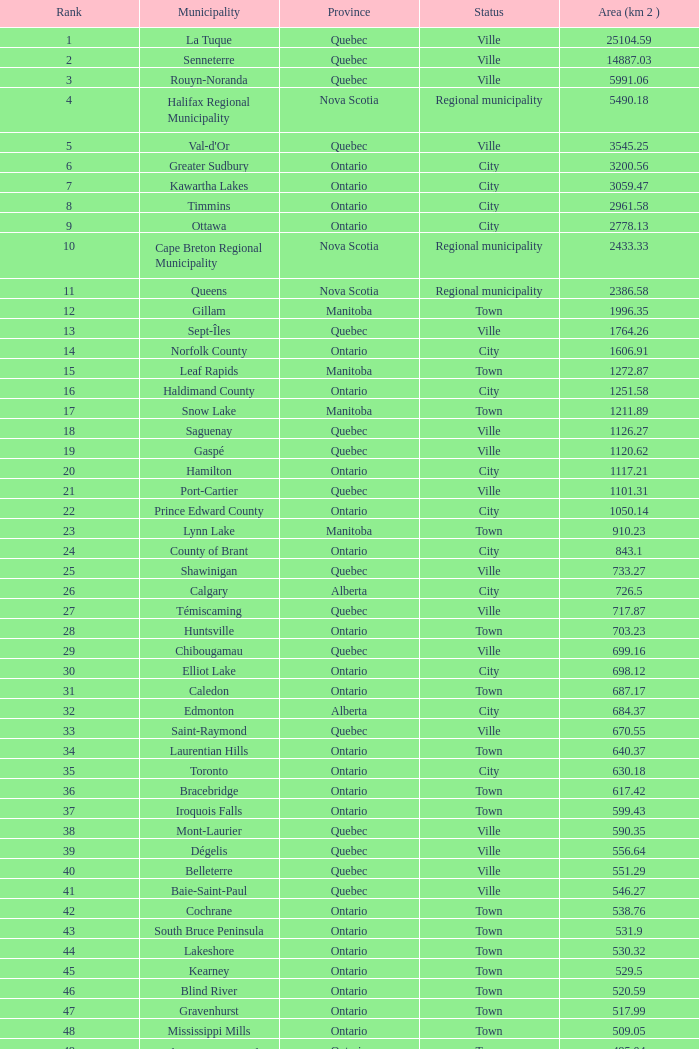Can you give me this table as a dict? {'header': ['Rank', 'Municipality', 'Province', 'Status', 'Area (km 2 )'], 'rows': [['1', 'La Tuque', 'Quebec', 'Ville', '25104.59'], ['2', 'Senneterre', 'Quebec', 'Ville', '14887.03'], ['3', 'Rouyn-Noranda', 'Quebec', 'Ville', '5991.06'], ['4', 'Halifax Regional Municipality', 'Nova Scotia', 'Regional municipality', '5490.18'], ['5', "Val-d'Or", 'Quebec', 'Ville', '3545.25'], ['6', 'Greater Sudbury', 'Ontario', 'City', '3200.56'], ['7', 'Kawartha Lakes', 'Ontario', 'City', '3059.47'], ['8', 'Timmins', 'Ontario', 'City', '2961.58'], ['9', 'Ottawa', 'Ontario', 'City', '2778.13'], ['10', 'Cape Breton Regional Municipality', 'Nova Scotia', 'Regional municipality', '2433.33'], ['11', 'Queens', 'Nova Scotia', 'Regional municipality', '2386.58'], ['12', 'Gillam', 'Manitoba', 'Town', '1996.35'], ['13', 'Sept-Îles', 'Quebec', 'Ville', '1764.26'], ['14', 'Norfolk County', 'Ontario', 'City', '1606.91'], ['15', 'Leaf Rapids', 'Manitoba', 'Town', '1272.87'], ['16', 'Haldimand County', 'Ontario', 'City', '1251.58'], ['17', 'Snow Lake', 'Manitoba', 'Town', '1211.89'], ['18', 'Saguenay', 'Quebec', 'Ville', '1126.27'], ['19', 'Gaspé', 'Quebec', 'Ville', '1120.62'], ['20', 'Hamilton', 'Ontario', 'City', '1117.21'], ['21', 'Port-Cartier', 'Quebec', 'Ville', '1101.31'], ['22', 'Prince Edward County', 'Ontario', 'City', '1050.14'], ['23', 'Lynn Lake', 'Manitoba', 'Town', '910.23'], ['24', 'County of Brant', 'Ontario', 'City', '843.1'], ['25', 'Shawinigan', 'Quebec', 'Ville', '733.27'], ['26', 'Calgary', 'Alberta', 'City', '726.5'], ['27', 'Témiscaming', 'Quebec', 'Ville', '717.87'], ['28', 'Huntsville', 'Ontario', 'Town', '703.23'], ['29', 'Chibougamau', 'Quebec', 'Ville', '699.16'], ['30', 'Elliot Lake', 'Ontario', 'City', '698.12'], ['31', 'Caledon', 'Ontario', 'Town', '687.17'], ['32', 'Edmonton', 'Alberta', 'City', '684.37'], ['33', 'Saint-Raymond', 'Quebec', 'Ville', '670.55'], ['34', 'Laurentian Hills', 'Ontario', 'Town', '640.37'], ['35', 'Toronto', 'Ontario', 'City', '630.18'], ['36', 'Bracebridge', 'Ontario', 'Town', '617.42'], ['37', 'Iroquois Falls', 'Ontario', 'Town', '599.43'], ['38', 'Mont-Laurier', 'Quebec', 'Ville', '590.35'], ['39', 'Dégelis', 'Quebec', 'Ville', '556.64'], ['40', 'Belleterre', 'Quebec', 'Ville', '551.29'], ['41', 'Baie-Saint-Paul', 'Quebec', 'Ville', '546.27'], ['42', 'Cochrane', 'Ontario', 'Town', '538.76'], ['43', 'South Bruce Peninsula', 'Ontario', 'Town', '531.9'], ['44', 'Lakeshore', 'Ontario', 'Town', '530.32'], ['45', 'Kearney', 'Ontario', 'Town', '529.5'], ['46', 'Blind River', 'Ontario', 'Town', '520.59'], ['47', 'Gravenhurst', 'Ontario', 'Town', '517.99'], ['48', 'Mississippi Mills', 'Ontario', 'Town', '509.05'], ['49', 'Northeastern Manitoulin and the Islands', 'Ontario', 'Town', '495.04'], ['50', 'Quinte West', 'Ontario', 'City', '493.85'], ['51', 'Mirabel', 'Quebec', 'Ville', '485.51'], ['52', 'Fermont', 'Quebec', 'Ville', '470.67'], ['53', 'Winnipeg', 'Manitoba', 'City', '464.01'], ['54', 'Greater Napanee', 'Ontario', 'Town', '459.71'], ['55', 'La Malbaie', 'Quebec', 'Ville', '459.34'], ['56', 'Rivière-Rouge', 'Quebec', 'Ville', '454.99'], ['57', 'Québec City', 'Quebec', 'Ville', '454.26'], ['58', 'Kingston', 'Ontario', 'City', '450.39'], ['59', 'Lévis', 'Quebec', 'Ville', '449.32'], ['60', "St. John's", 'Newfoundland and Labrador', 'City', '446.04'], ['61', 'Bécancour', 'Quebec', 'Ville', '441'], ['62', 'Percé', 'Quebec', 'Ville', '432.39'], ['63', 'Amos', 'Quebec', 'Ville', '430.06'], ['64', 'London', 'Ontario', 'City', '420.57'], ['65', 'Chandler', 'Quebec', 'Ville', '419.5'], ['66', 'Whitehorse', 'Yukon', 'City', '416.43'], ['67', 'Gracefield', 'Quebec', 'Ville', '386.21'], ['68', 'Baie Verte', 'Newfoundland and Labrador', 'Town', '371.07'], ['69', 'Milton', 'Ontario', 'Town', '366.61'], ['70', 'Montreal', 'Quebec', 'Ville', '365.13'], ['71', 'Saint-Félicien', 'Quebec', 'Ville', '363.57'], ['72', 'Abbotsford', 'British Columbia', 'City', '359.36'], ['73', 'Sherbrooke', 'Quebec', 'Ville', '353.46'], ['74', 'Gatineau', 'Quebec', 'Ville', '342.32'], ['75', 'Pohénégamook', 'Quebec', 'Ville', '340.33'], ['76', 'Baie-Comeau', 'Quebec', 'Ville', '338.88'], ['77', 'Thunder Bay', 'Ontario', 'City', '328.48'], ['78', 'Plympton–Wyoming', 'Ontario', 'Town', '318.76'], ['79', 'Surrey', 'British Columbia', 'City', '317.19'], ['80', 'Prince George', 'British Columbia', 'City', '316'], ['81', 'Saint John', 'New Brunswick', 'City', '315.49'], ['82', 'North Bay', 'Ontario', 'City', '314.91'], ['83', 'Happy Valley-Goose Bay', 'Newfoundland and Labrador', 'Town', '305.85'], ['84', 'Minto', 'Ontario', 'Town', '300.37'], ['85', 'Kamloops', 'British Columbia', 'City', '297.3'], ['86', 'Erin', 'Ontario', 'Town', '296.98'], ['87', 'Clarence-Rockland', 'Ontario', 'City', '296.53'], ['88', 'Cookshire-Eaton', 'Quebec', 'Ville', '295.93'], ['89', 'Dolbeau-Mistassini', 'Quebec', 'Ville', '295.67'], ['90', 'Trois-Rivières', 'Quebec', 'Ville', '288.92'], ['91', 'Mississauga', 'Ontario', 'City', '288.53'], ['92', 'Georgina', 'Ontario', 'Town', '287.72'], ['93', 'The Blue Mountains', 'Ontario', 'Town', '286.78'], ['94', 'Innisfil', 'Ontario', 'Town', '284.18'], ['95', 'Essex', 'Ontario', 'Town', '277.95'], ['96', 'Mono', 'Ontario', 'Town', '277.67'], ['97', 'Halton Hills', 'Ontario', 'Town', '276.26'], ['98', 'New Tecumseth', 'Ontario', 'Town', '274.18'], ['99', 'Vaughan', 'Ontario', 'City', '273.58'], ['100', 'Brampton', 'Ontario', 'City', '266.71']]} What is the overall rank with a 1050.14 km 2 area? 22.0. 